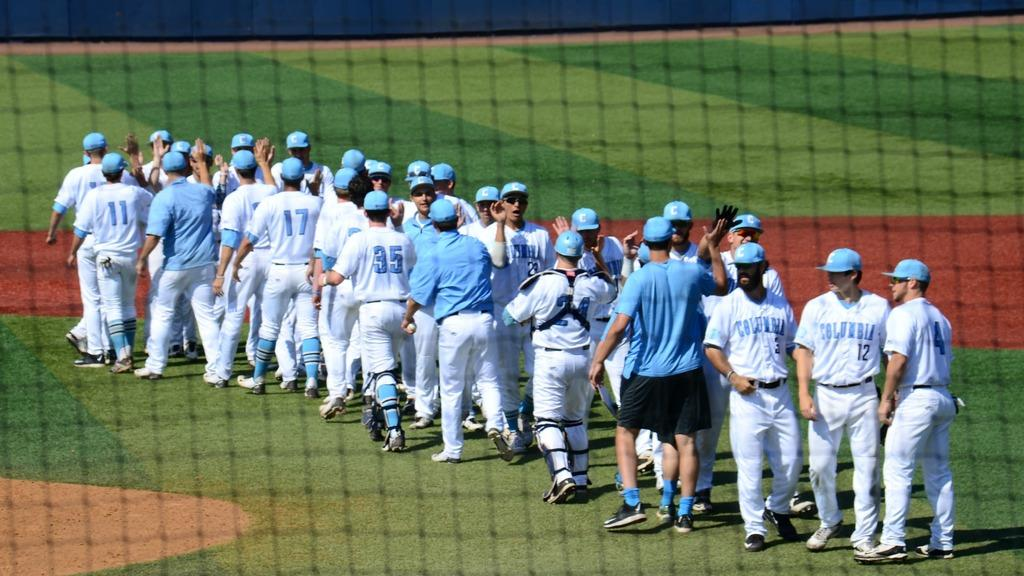Who or what can be seen in the image? There are people in the image. What is the surface beneath the people's feet? The ground is visible in the image. What type of vegetation is present on the ground? Grass is present on the ground. What object is visible in the image that might be used for a specific activity? There is a net in the image. What type of song can be heard playing in the background of the image? There is no indication of any sound or song in the image, as it only shows people, the ground, grass, and a net. 